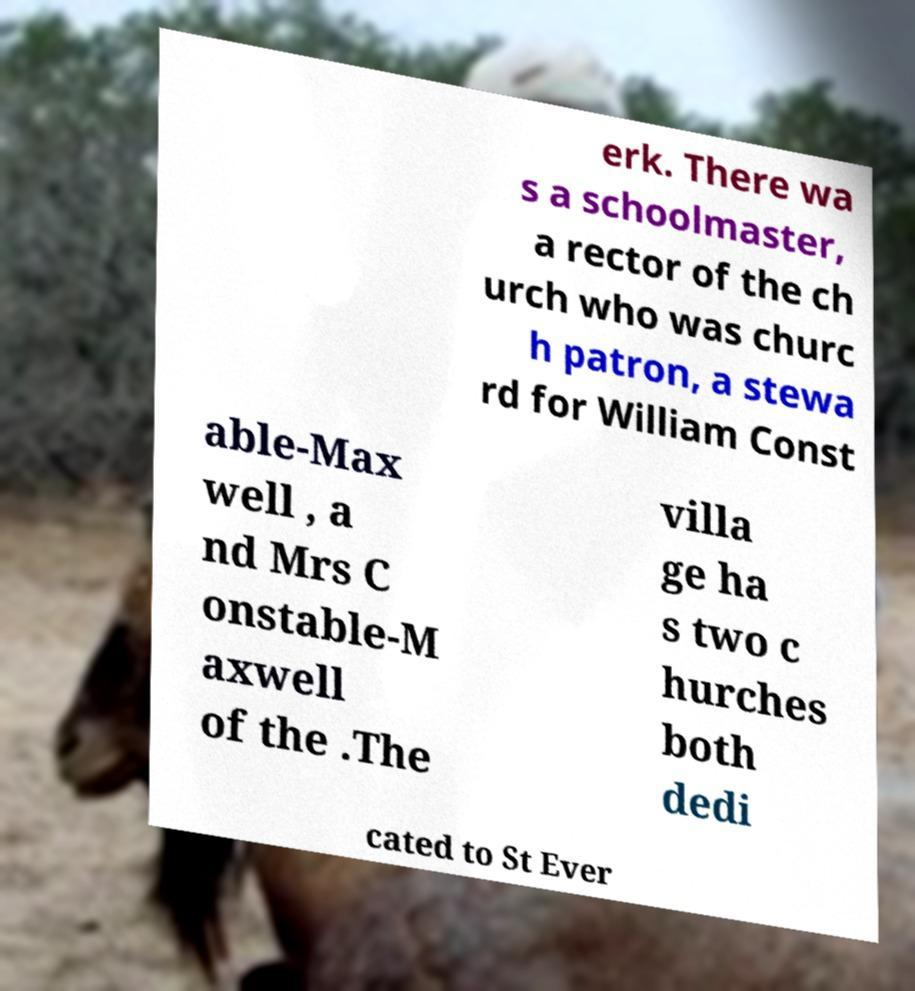Please identify and transcribe the text found in this image. erk. There wa s a schoolmaster, a rector of the ch urch who was churc h patron, a stewa rd for William Const able-Max well , a nd Mrs C onstable-M axwell of the .The villa ge ha s two c hurches both dedi cated to St Ever 